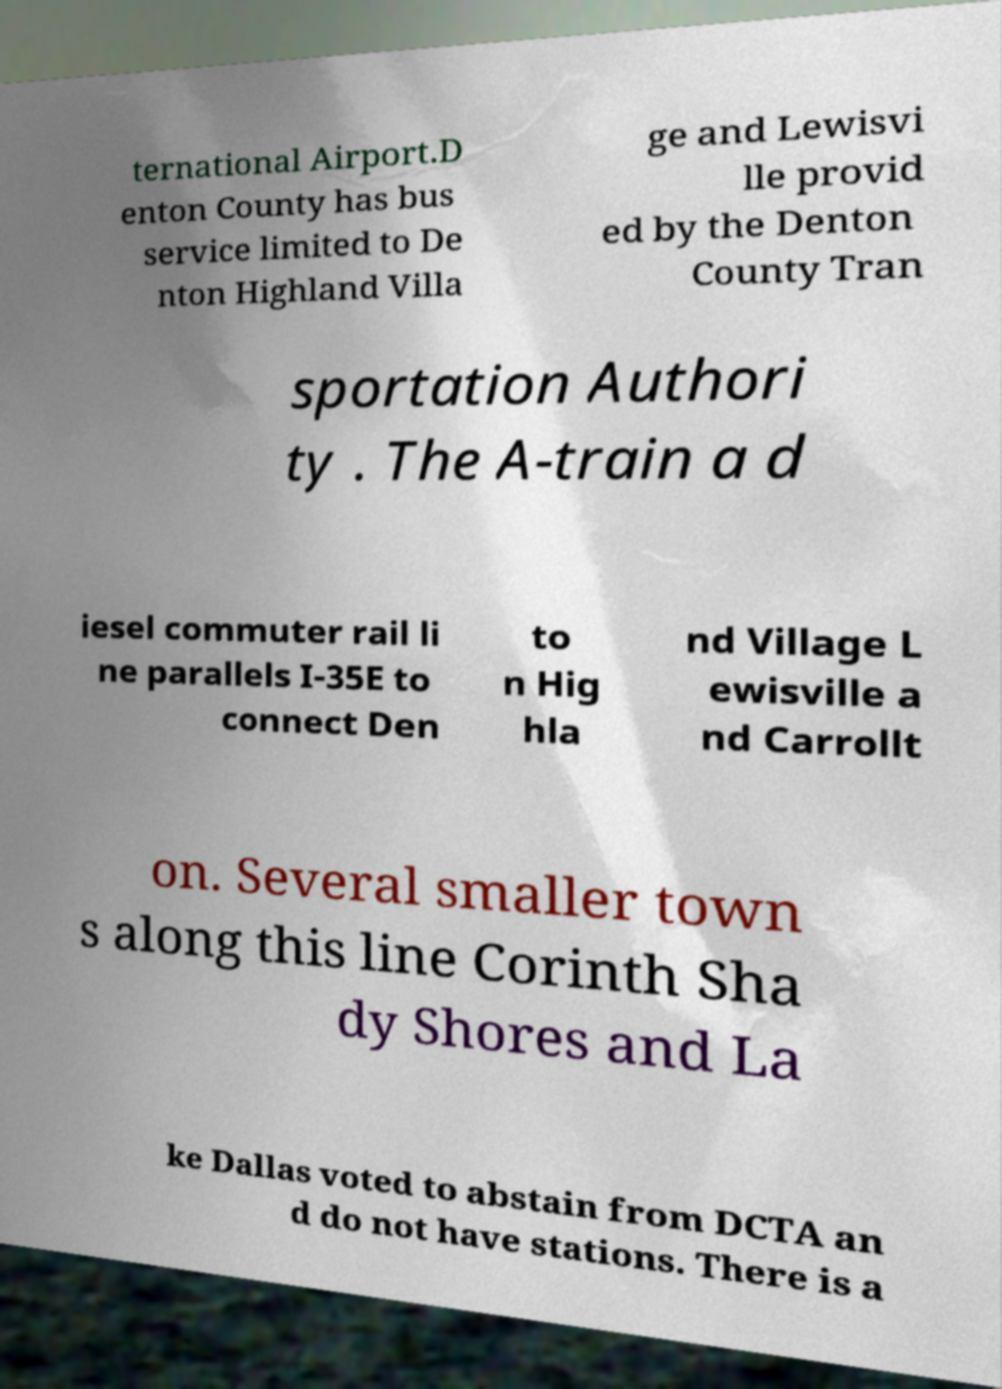I need the written content from this picture converted into text. Can you do that? ternational Airport.D enton County has bus service limited to De nton Highland Villa ge and Lewisvi lle provid ed by the Denton County Tran sportation Authori ty . The A-train a d iesel commuter rail li ne parallels I-35E to connect Den to n Hig hla nd Village L ewisville a nd Carrollt on. Several smaller town s along this line Corinth Sha dy Shores and La ke Dallas voted to abstain from DCTA an d do not have stations. There is a 